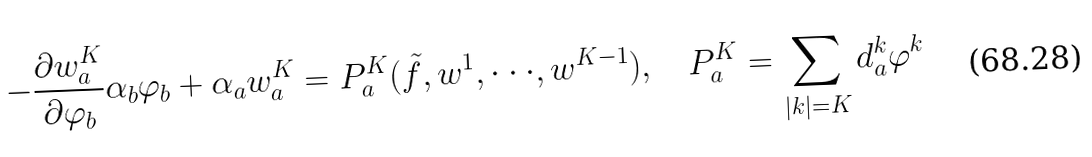<formula> <loc_0><loc_0><loc_500><loc_500>- \frac { \partial w ^ { K } _ { a } } { \partial \varphi _ { b } } \alpha _ { b } \varphi _ { b } + \alpha _ { a } w ^ { K } _ { a } = P ^ { K } _ { a } ( \tilde { f } , w ^ { 1 } , \cdot \cdot \cdot , w ^ { K - 1 } ) , \quad P ^ { K } _ { a } = \sum _ { | k | = K } d ^ { k } _ { a } \varphi ^ { k }</formula> 